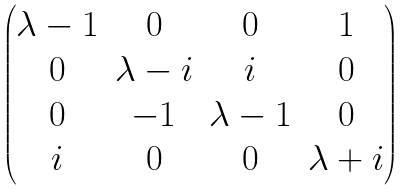Convert formula to latex. <formula><loc_0><loc_0><loc_500><loc_500>\begin{pmatrix} \lambda - 1 & 0 & 0 & 1 \\ 0 & \lambda - i & i & 0 \\ 0 & - 1 & \lambda - 1 & 0 \\ i & 0 & 0 & \lambda + i \end{pmatrix}</formula> 